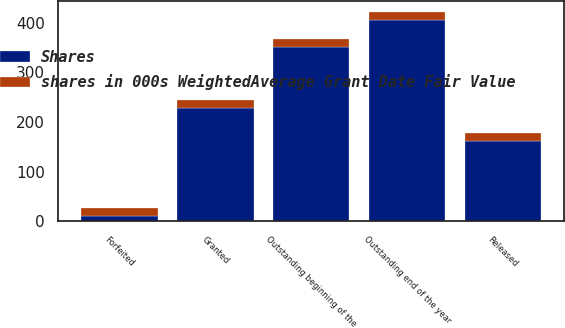Convert chart. <chart><loc_0><loc_0><loc_500><loc_500><stacked_bar_chart><ecel><fcel>Outstanding beginning of the<fcel>Granted<fcel>Released<fcel>Forfeited<fcel>Outstanding end of the year<nl><fcel>Shares<fcel>350<fcel>228<fcel>162<fcel>10<fcel>406<nl><fcel>shares in 000s WeightedAverage Grant Date Fair Value<fcel>17.3<fcel>15.75<fcel>16.71<fcel>16.89<fcel>16.07<nl></chart> 